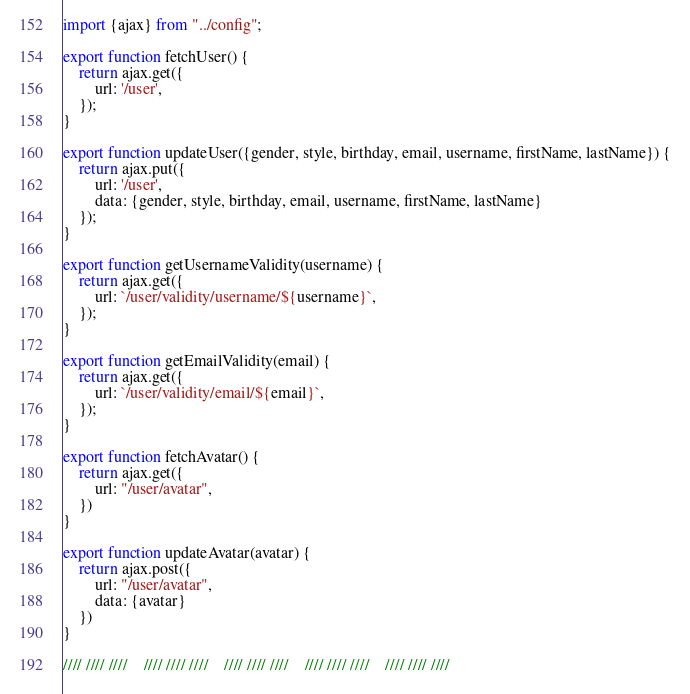<code> <loc_0><loc_0><loc_500><loc_500><_JavaScript_>import {ajax} from "../config";

export function fetchUser() {
    return ajax.get({
        url: '/user',
    });
}

export function updateUser({gender, style, birthday, email, username, firstName, lastName}) {
    return ajax.put({
        url: '/user',
        data: {gender, style, birthday, email, username, firstName, lastName}
    });
}

export function getUsernameValidity(username) {
    return ajax.get({
        url: `/user/validity/username/${username}`,
    });
}

export function getEmailValidity(email) {
    return ajax.get({
        url: `/user/validity/email/${email}`,
    });
}

export function fetchAvatar() {
    return ajax.get({
        url: "/user/avatar",
    })
}

export function updateAvatar(avatar) {
    return ajax.post({
        url: "/user/avatar",
        data: {avatar}
    })
}

//// //// ////    //// //// ////    //// //// ////    //// //// ////    //// //// ////

</code> 